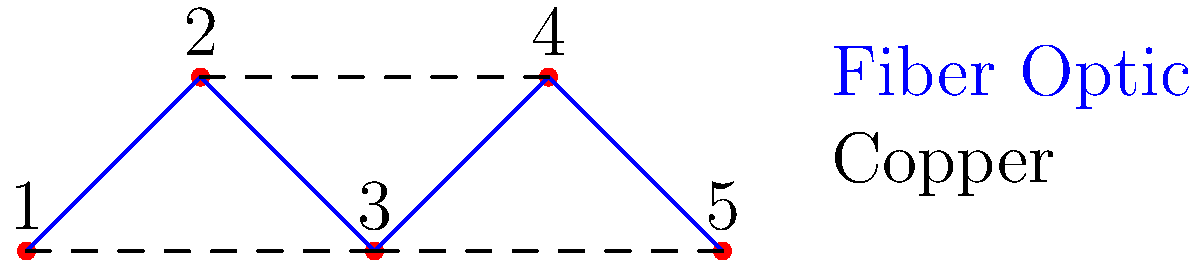A startup in Seoul National Univ. Venture Town is optimizing their network topology. The diagram shows 5 nodes connected by fiber optic (solid blue) and copper (dashed) links. If the startup wants to minimize latency while ensuring all nodes are connected, how many copper links can be removed without disconnecting the network? To solve this problem, we need to follow these steps:

1. Identify the total number of links:
   - There are 4 fiber optic links and 3 copper links.

2. Determine the minimum number of links required to keep all nodes connected:
   - For 5 nodes, we need at least 4 links to form a minimum spanning tree.

3. Prioritize fiber optic links due to lower latency:
   - The 4 fiber optic links already form a connected network (1-2-3-4-5).

4. Analyze each copper link:
   - Link 1-3: Can be removed as 1 and 3 are already connected through 2.
   - Link 2-4: Can be removed as 2 and 4 are already connected through 3.
   - Link 3-5: Can be removed as 3 and 5 are already connected through 4.

5. Conclude:
   - All 3 copper links can be removed without disconnecting the network.

The fiber optic links alone provide the minimum latency connection for all nodes.
Answer: 3 copper links 